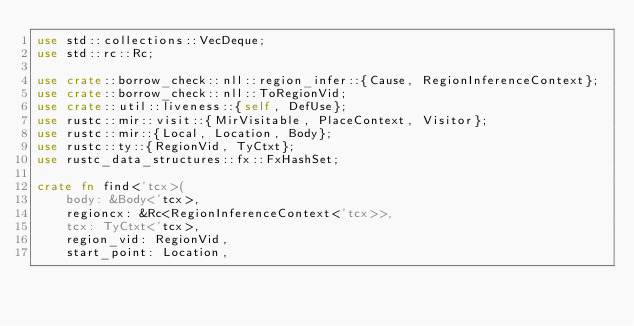<code> <loc_0><loc_0><loc_500><loc_500><_Rust_>use std::collections::VecDeque;
use std::rc::Rc;

use crate::borrow_check::nll::region_infer::{Cause, RegionInferenceContext};
use crate::borrow_check::nll::ToRegionVid;
use crate::util::liveness::{self, DefUse};
use rustc::mir::visit::{MirVisitable, PlaceContext, Visitor};
use rustc::mir::{Local, Location, Body};
use rustc::ty::{RegionVid, TyCtxt};
use rustc_data_structures::fx::FxHashSet;

crate fn find<'tcx>(
    body: &Body<'tcx>,
    regioncx: &Rc<RegionInferenceContext<'tcx>>,
    tcx: TyCtxt<'tcx>,
    region_vid: RegionVid,
    start_point: Location,</code> 